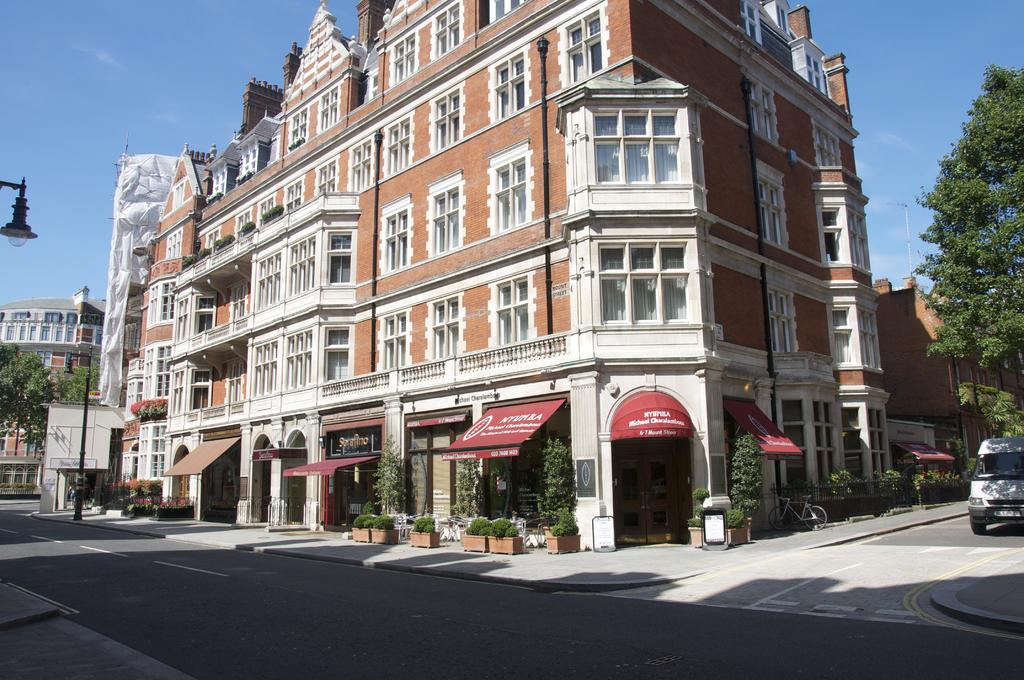What is the color of the building in the image? The building in the image is brown-colored. What can be found in the image besides the building? There are stalls, trees, vehicles, light poles, and the sky visible in the image. What color are the trees in the background? The trees in the background are green in color. What might be used for illumination at night in the image? Light poles are present in the image for illumination. What is the color of the sky in the image? The sky is blue in color. What type of joke can be heard coming from the stalls in the image? There is no indication of any jokes or sounds coming from the stalls in the image. Are there any bears visible in the image? No, there are no bears present in the image. 